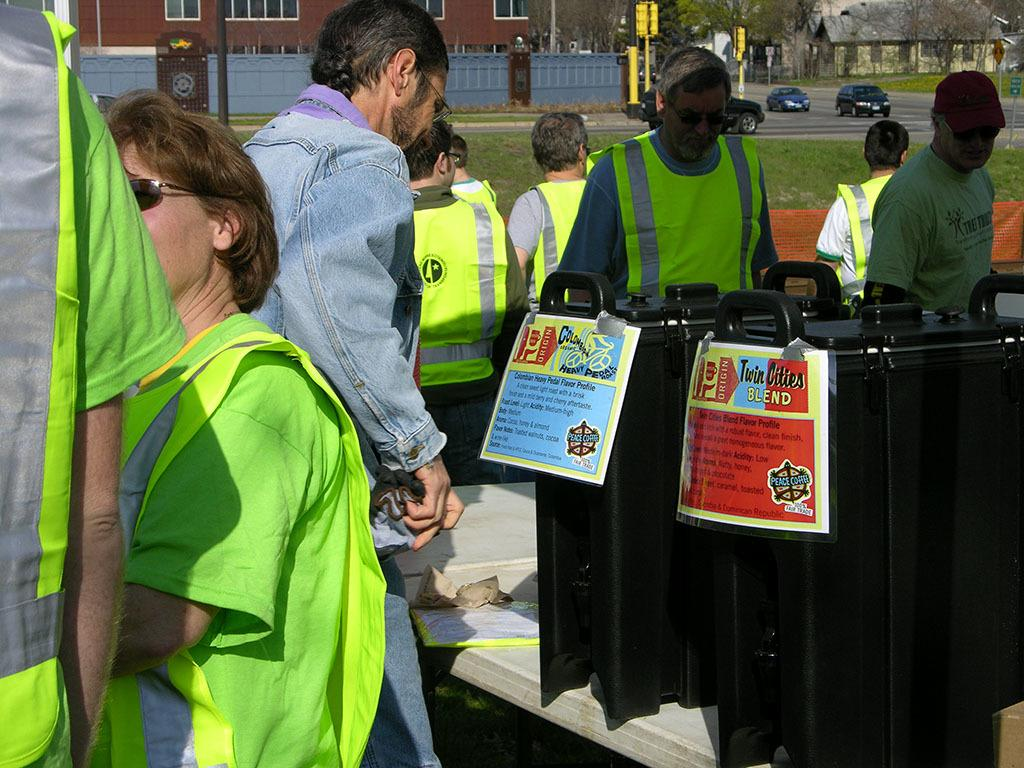<image>
Summarize the visual content of the image. A coffee pot is labeled Twin Cities Blend and stands next to another pot. 